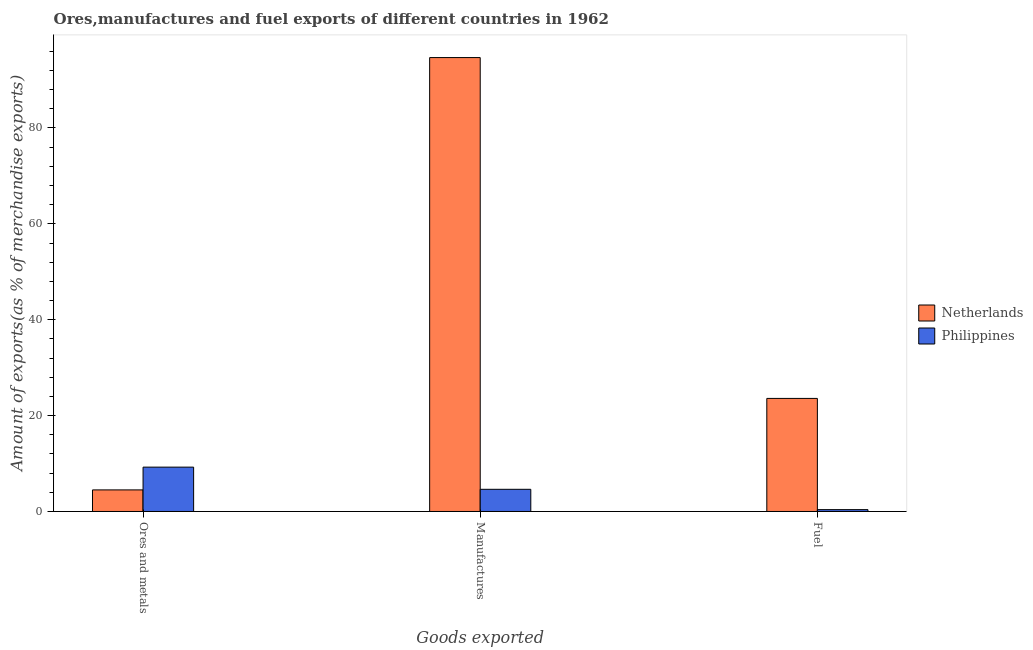Are the number of bars per tick equal to the number of legend labels?
Make the answer very short. Yes. How many bars are there on the 2nd tick from the left?
Your answer should be compact. 2. What is the label of the 3rd group of bars from the left?
Your answer should be compact. Fuel. What is the percentage of manufactures exports in Netherlands?
Your response must be concise. 94.68. Across all countries, what is the maximum percentage of ores and metals exports?
Provide a short and direct response. 9.25. Across all countries, what is the minimum percentage of fuel exports?
Ensure brevity in your answer.  0.38. In which country was the percentage of fuel exports minimum?
Your answer should be very brief. Philippines. What is the total percentage of ores and metals exports in the graph?
Your answer should be very brief. 13.75. What is the difference between the percentage of fuel exports in Netherlands and that in Philippines?
Offer a terse response. 23.2. What is the difference between the percentage of ores and metals exports in Philippines and the percentage of fuel exports in Netherlands?
Give a very brief answer. -14.33. What is the average percentage of fuel exports per country?
Keep it short and to the point. 11.98. What is the difference between the percentage of manufactures exports and percentage of fuel exports in Philippines?
Make the answer very short. 4.24. What is the ratio of the percentage of fuel exports in Philippines to that in Netherlands?
Offer a terse response. 0.02. What is the difference between the highest and the second highest percentage of fuel exports?
Provide a succinct answer. 23.2. What is the difference between the highest and the lowest percentage of ores and metals exports?
Your answer should be compact. 4.75. What does the 1st bar from the left in Ores and metals represents?
Provide a short and direct response. Netherlands. Is it the case that in every country, the sum of the percentage of ores and metals exports and percentage of manufactures exports is greater than the percentage of fuel exports?
Your answer should be compact. Yes. Are all the bars in the graph horizontal?
Your response must be concise. No. What is the difference between two consecutive major ticks on the Y-axis?
Make the answer very short. 20. Does the graph contain any zero values?
Provide a succinct answer. No. How many legend labels are there?
Keep it short and to the point. 2. What is the title of the graph?
Ensure brevity in your answer.  Ores,manufactures and fuel exports of different countries in 1962. Does "Maldives" appear as one of the legend labels in the graph?
Your answer should be compact. No. What is the label or title of the X-axis?
Offer a very short reply. Goods exported. What is the label or title of the Y-axis?
Make the answer very short. Amount of exports(as % of merchandise exports). What is the Amount of exports(as % of merchandise exports) in Netherlands in Ores and metals?
Your response must be concise. 4.5. What is the Amount of exports(as % of merchandise exports) in Philippines in Ores and metals?
Make the answer very short. 9.25. What is the Amount of exports(as % of merchandise exports) of Netherlands in Manufactures?
Your answer should be compact. 94.68. What is the Amount of exports(as % of merchandise exports) in Philippines in Manufactures?
Give a very brief answer. 4.63. What is the Amount of exports(as % of merchandise exports) in Netherlands in Fuel?
Make the answer very short. 23.58. What is the Amount of exports(as % of merchandise exports) in Philippines in Fuel?
Ensure brevity in your answer.  0.38. Across all Goods exported, what is the maximum Amount of exports(as % of merchandise exports) in Netherlands?
Your answer should be very brief. 94.68. Across all Goods exported, what is the maximum Amount of exports(as % of merchandise exports) in Philippines?
Offer a terse response. 9.25. Across all Goods exported, what is the minimum Amount of exports(as % of merchandise exports) in Netherlands?
Your response must be concise. 4.5. Across all Goods exported, what is the minimum Amount of exports(as % of merchandise exports) in Philippines?
Ensure brevity in your answer.  0.38. What is the total Amount of exports(as % of merchandise exports) of Netherlands in the graph?
Keep it short and to the point. 122.76. What is the total Amount of exports(as % of merchandise exports) of Philippines in the graph?
Your answer should be compact. 14.26. What is the difference between the Amount of exports(as % of merchandise exports) of Netherlands in Ores and metals and that in Manufactures?
Provide a short and direct response. -90.18. What is the difference between the Amount of exports(as % of merchandise exports) of Philippines in Ores and metals and that in Manufactures?
Your answer should be compact. 4.62. What is the difference between the Amount of exports(as % of merchandise exports) of Netherlands in Ores and metals and that in Fuel?
Keep it short and to the point. -19.08. What is the difference between the Amount of exports(as % of merchandise exports) of Philippines in Ores and metals and that in Fuel?
Provide a succinct answer. 8.87. What is the difference between the Amount of exports(as % of merchandise exports) in Netherlands in Manufactures and that in Fuel?
Your response must be concise. 71.09. What is the difference between the Amount of exports(as % of merchandise exports) of Philippines in Manufactures and that in Fuel?
Make the answer very short. 4.24. What is the difference between the Amount of exports(as % of merchandise exports) of Netherlands in Ores and metals and the Amount of exports(as % of merchandise exports) of Philippines in Manufactures?
Provide a succinct answer. -0.13. What is the difference between the Amount of exports(as % of merchandise exports) of Netherlands in Ores and metals and the Amount of exports(as % of merchandise exports) of Philippines in Fuel?
Provide a short and direct response. 4.12. What is the difference between the Amount of exports(as % of merchandise exports) of Netherlands in Manufactures and the Amount of exports(as % of merchandise exports) of Philippines in Fuel?
Your response must be concise. 94.29. What is the average Amount of exports(as % of merchandise exports) in Netherlands per Goods exported?
Provide a succinct answer. 40.92. What is the average Amount of exports(as % of merchandise exports) in Philippines per Goods exported?
Make the answer very short. 4.75. What is the difference between the Amount of exports(as % of merchandise exports) of Netherlands and Amount of exports(as % of merchandise exports) of Philippines in Ores and metals?
Keep it short and to the point. -4.75. What is the difference between the Amount of exports(as % of merchandise exports) in Netherlands and Amount of exports(as % of merchandise exports) in Philippines in Manufactures?
Your answer should be compact. 90.05. What is the difference between the Amount of exports(as % of merchandise exports) of Netherlands and Amount of exports(as % of merchandise exports) of Philippines in Fuel?
Keep it short and to the point. 23.2. What is the ratio of the Amount of exports(as % of merchandise exports) of Netherlands in Ores and metals to that in Manufactures?
Keep it short and to the point. 0.05. What is the ratio of the Amount of exports(as % of merchandise exports) in Philippines in Ores and metals to that in Manufactures?
Your response must be concise. 2. What is the ratio of the Amount of exports(as % of merchandise exports) of Netherlands in Ores and metals to that in Fuel?
Provide a short and direct response. 0.19. What is the ratio of the Amount of exports(as % of merchandise exports) in Philippines in Ores and metals to that in Fuel?
Your answer should be very brief. 24.03. What is the ratio of the Amount of exports(as % of merchandise exports) in Netherlands in Manufactures to that in Fuel?
Your answer should be very brief. 4.01. What is the ratio of the Amount of exports(as % of merchandise exports) in Philippines in Manufactures to that in Fuel?
Ensure brevity in your answer.  12.02. What is the difference between the highest and the second highest Amount of exports(as % of merchandise exports) in Netherlands?
Offer a terse response. 71.09. What is the difference between the highest and the second highest Amount of exports(as % of merchandise exports) in Philippines?
Your response must be concise. 4.62. What is the difference between the highest and the lowest Amount of exports(as % of merchandise exports) of Netherlands?
Offer a very short reply. 90.18. What is the difference between the highest and the lowest Amount of exports(as % of merchandise exports) in Philippines?
Your answer should be very brief. 8.87. 